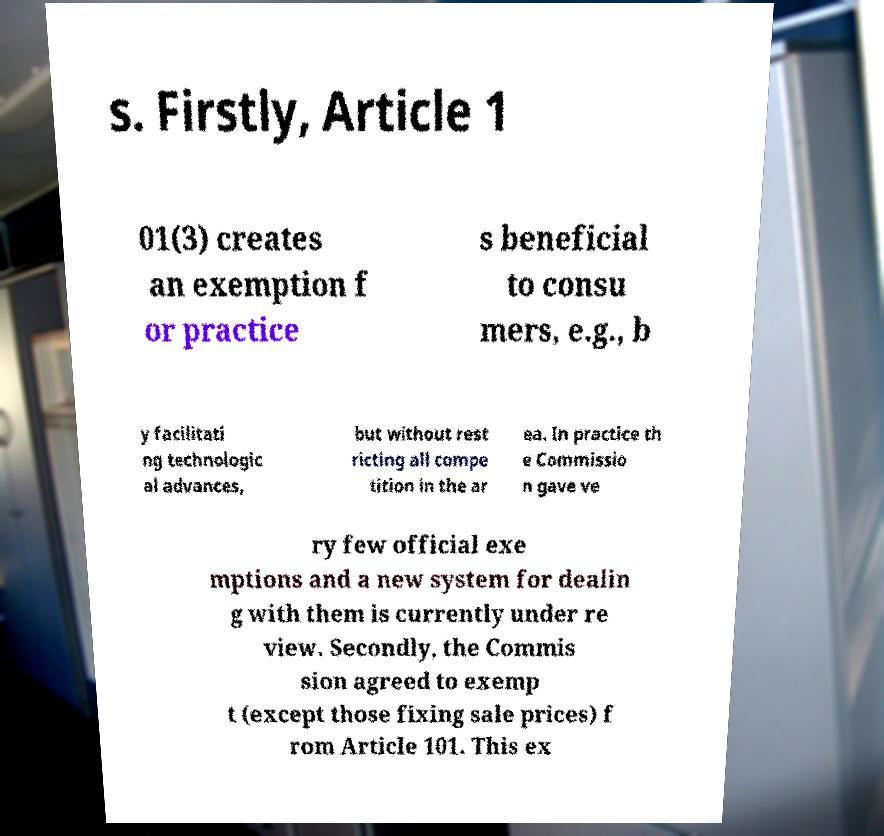Could you assist in decoding the text presented in this image and type it out clearly? s. Firstly, Article 1 01(3) creates an exemption f or practice s beneficial to consu mers, e.g., b y facilitati ng technologic al advances, but without rest ricting all compe tition in the ar ea. In practice th e Commissio n gave ve ry few official exe mptions and a new system for dealin g with them is currently under re view. Secondly, the Commis sion agreed to exemp t (except those fixing sale prices) f rom Article 101. This ex 